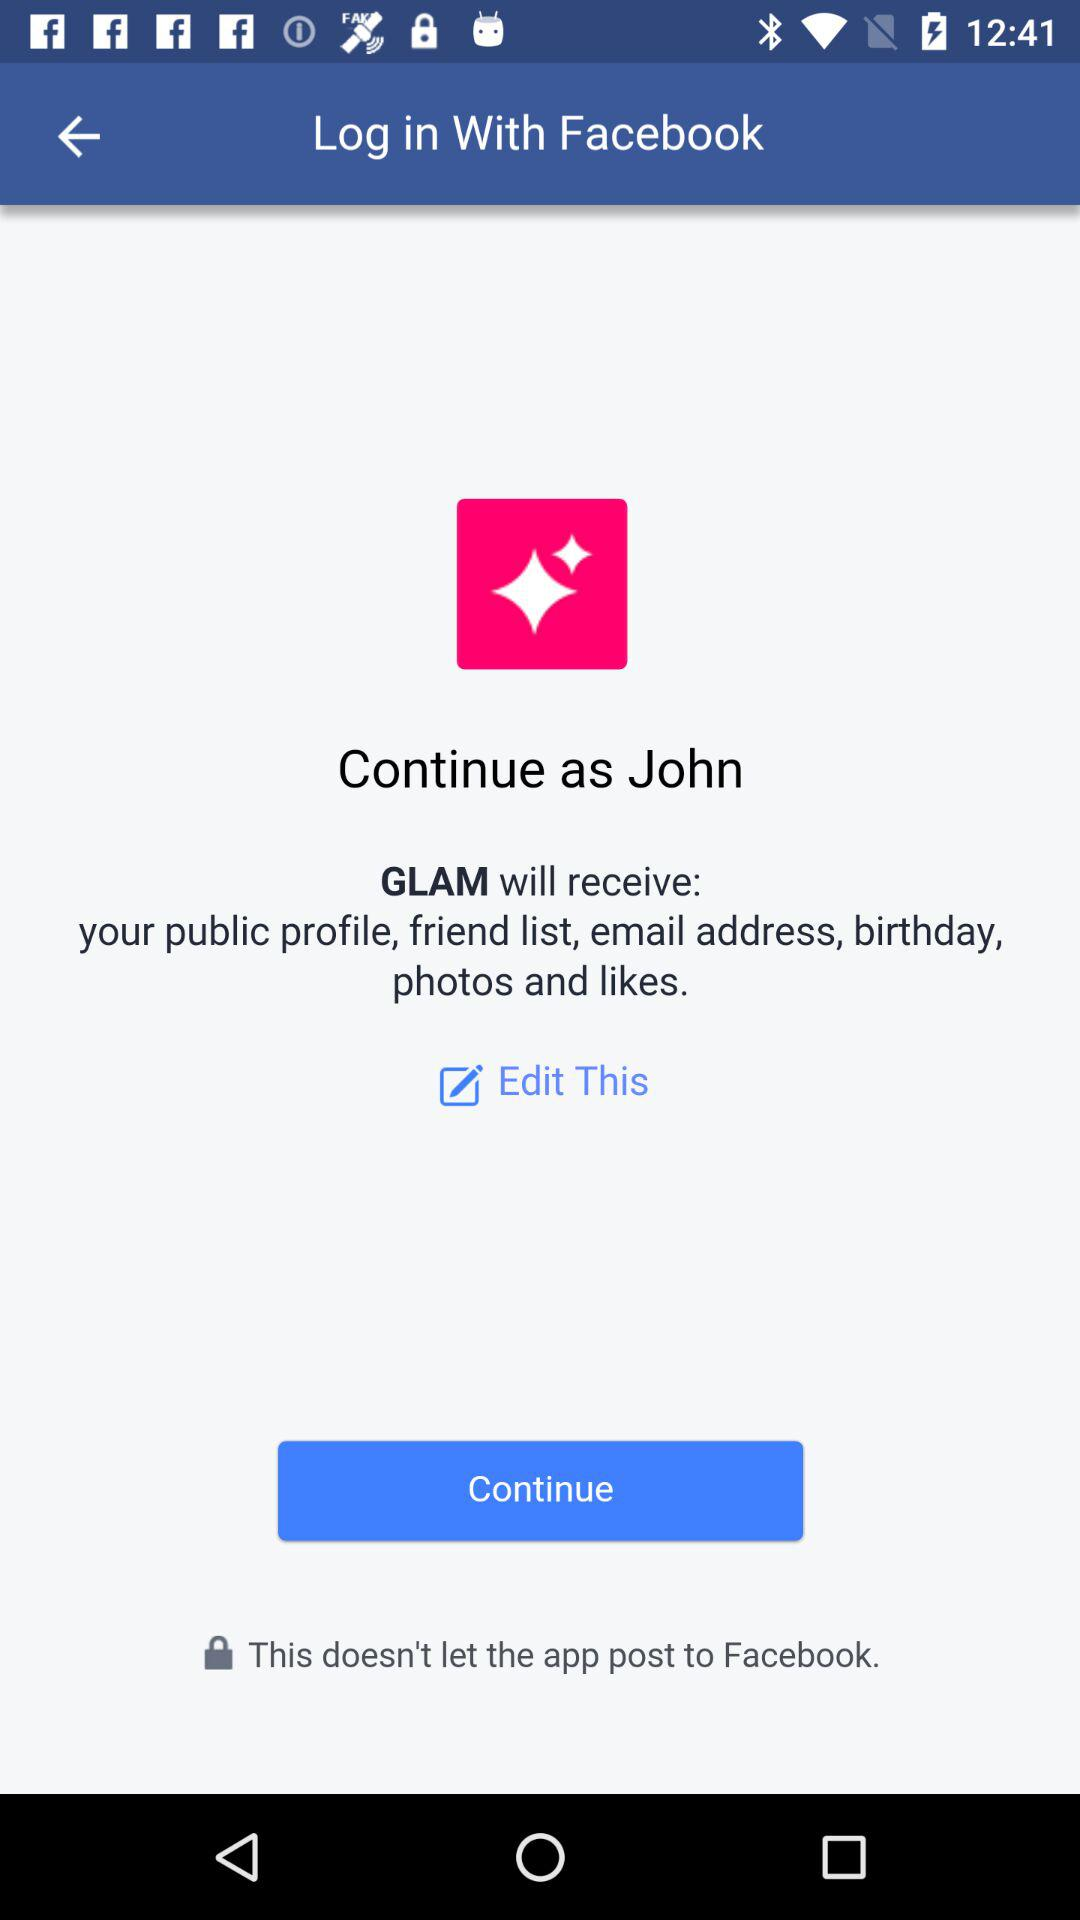Which option is selected?
When the provided information is insufficient, respond with <no answer>. <no answer> 